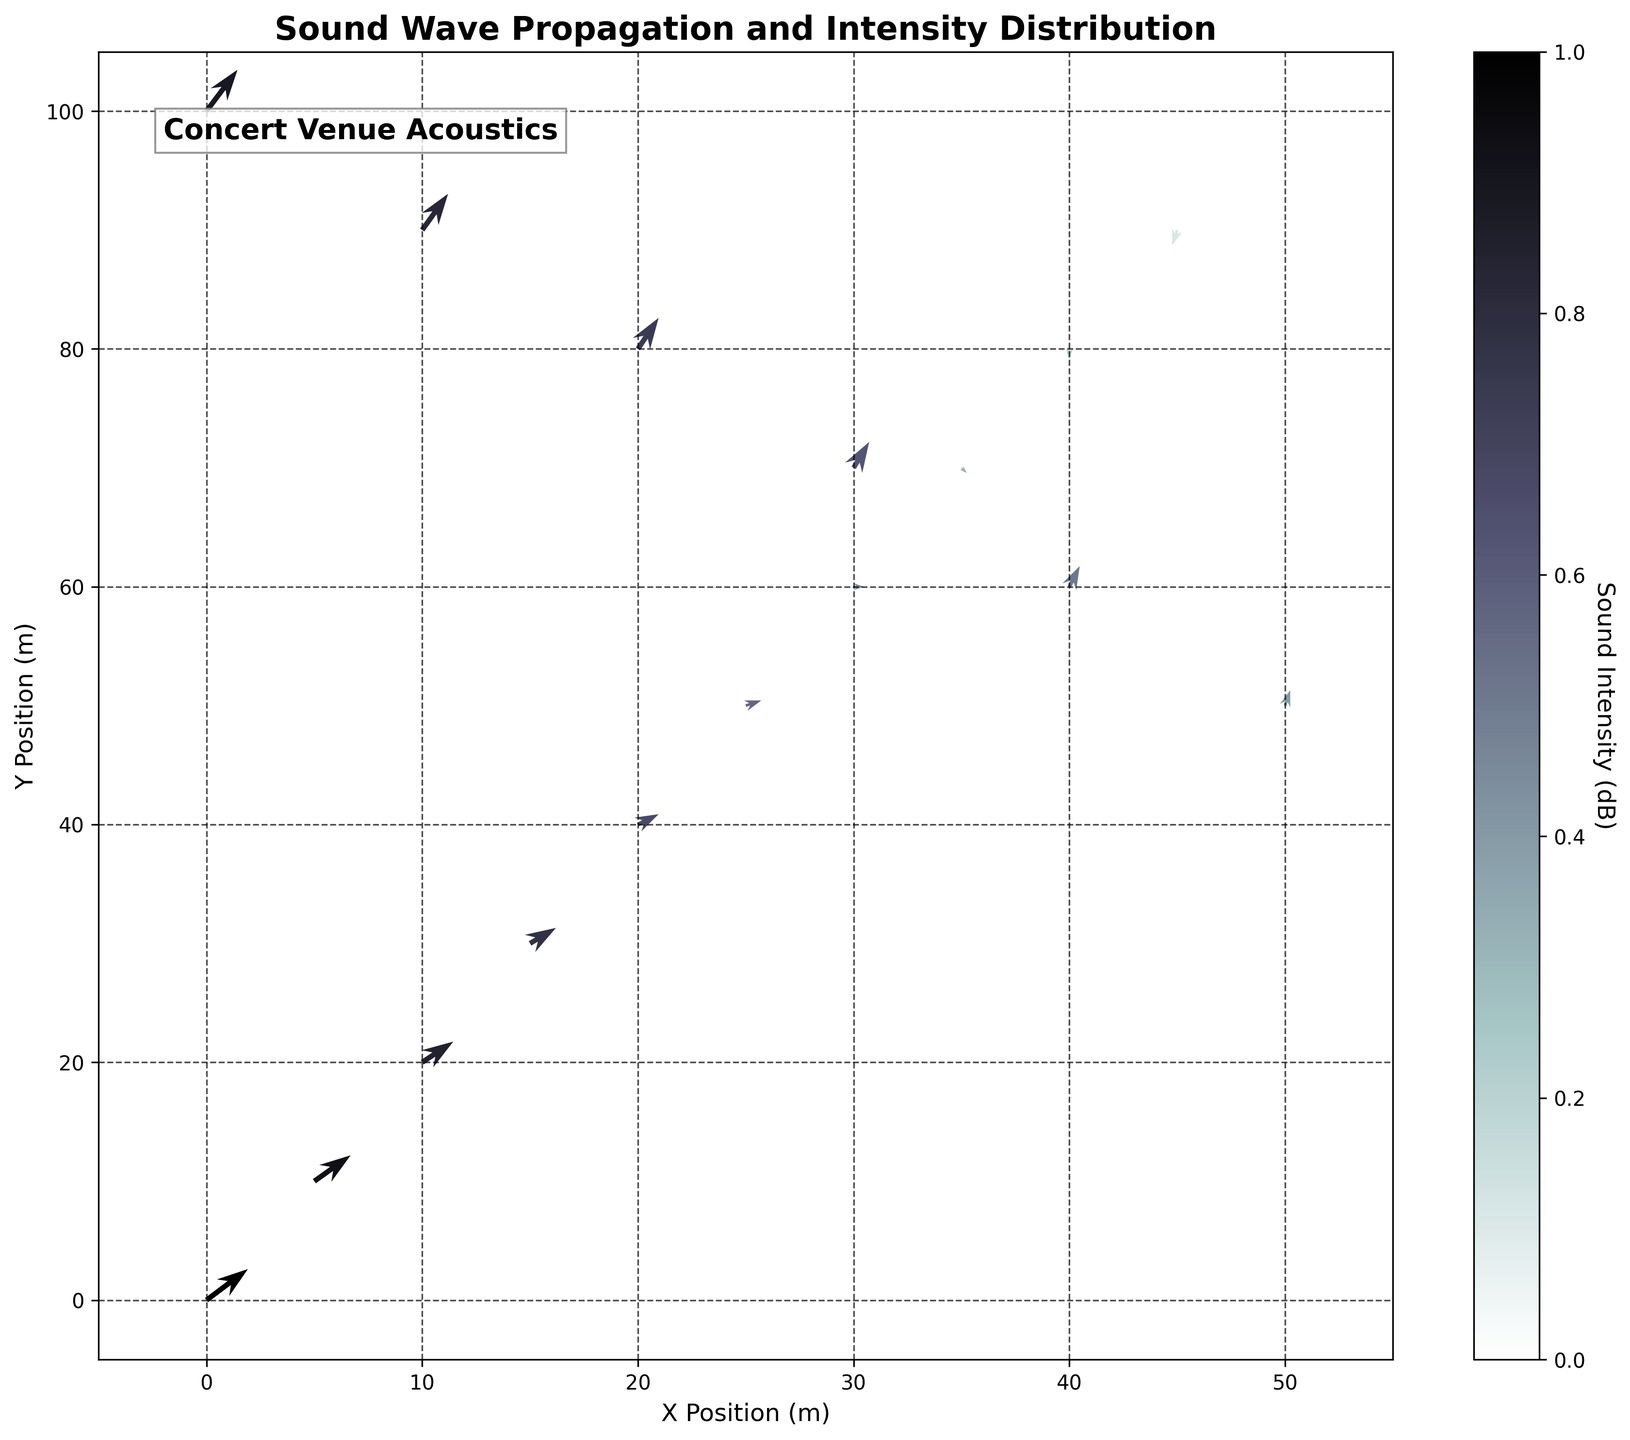How many data points are represented in the quiver plot? Count the number of arrow origins indicated by the x, y coordinates. There are 17 such pairs in the provided data.
Answer: 17 What does the color of the arrows represent in the quiver plot? The color represents the normalized sound intensity (dB) at different points in the concert venue. Darker arrows indicate higher intensity and lighter arrows indicate lower intensity.
Answer: Sound Intensity Which point has the highest sound intensity and what is its value? The first point (0, 0) has the highest sound intensity of 95 dB. This is determined by identifying the maximum value in the intensity column.
Answer: 95 dB How does the direction of the vectors change as the sound intensity decreases? The vectors generally point downward and decrease in magnitude as the intensity decreases. Initially, they point upwards and towards the right but progressively rotate downward.
Answer: Downward Is there any point where the vectors are pointing vertically downwards? If yes, what are the coordinates? Yes, the vectors at coordinate (40,80) are pointing vertically downwards. This is verified by checking the direction components u=0.0 and v=-0.2.
Answer: (40,80) How does the intensity differ between the x-coordinate 0 and x-coordinate 30 at the same y-coordinates on each row where data is available? At y-coordinate 0, the intensity is 95 dB at x=0 and 70 dB at x=30. The difference is 95 - 70 = 25 dB. At y-coordinate 100, it's 90 dB at x=0 and 68 dB at x=50, the difference is 90 - 68 = 22 dB.
Answer: 25 dB, 22 dB Which side of the venue has a more intense sound distribution, the left side (x=0 to 25) or the right side (x=30 to 50)? Calculate the average intensity for the left side and the right side. For x=0 to 25: (95+92+88+85+80+75)/6 = 85.83 dB. For x=30 to 50: (70+65+60+55+50+68)/6 = 61.33 dB. The left side has a more intense sound distribution.
Answer: Left side What trends can you observe in the direction of sound waves as they move from the stage area (close to x=0, y=0)? Initially, the sound waves move upward and to the right (positive u, v values). As they move farther from the stage, the vectors progressively point downward, indicating a dispersion and a possible decrease in sound intensity.
Answer: Upward to Downward How does the scale of the arrows affect the visual interpretation of the sound propagation? The scale is set to 25, which affects the length of the arrows representing the sound waves. A larger scale would make arrows appear longer and exaggerate the propagation effect, while a smaller scale would shorten them, potentially making the propagation less noticeable visually.
Answer: Length exaggeration At which coordinate does the sound intensity change direction from positive to negative in the x component (u)? The change occurs at the coordinate (45, 90). Before this point, all x components (u) are positive or zero. At (45, 90), the u component is -0.1, indicating a change to negative.
Answer: (45, 90) 